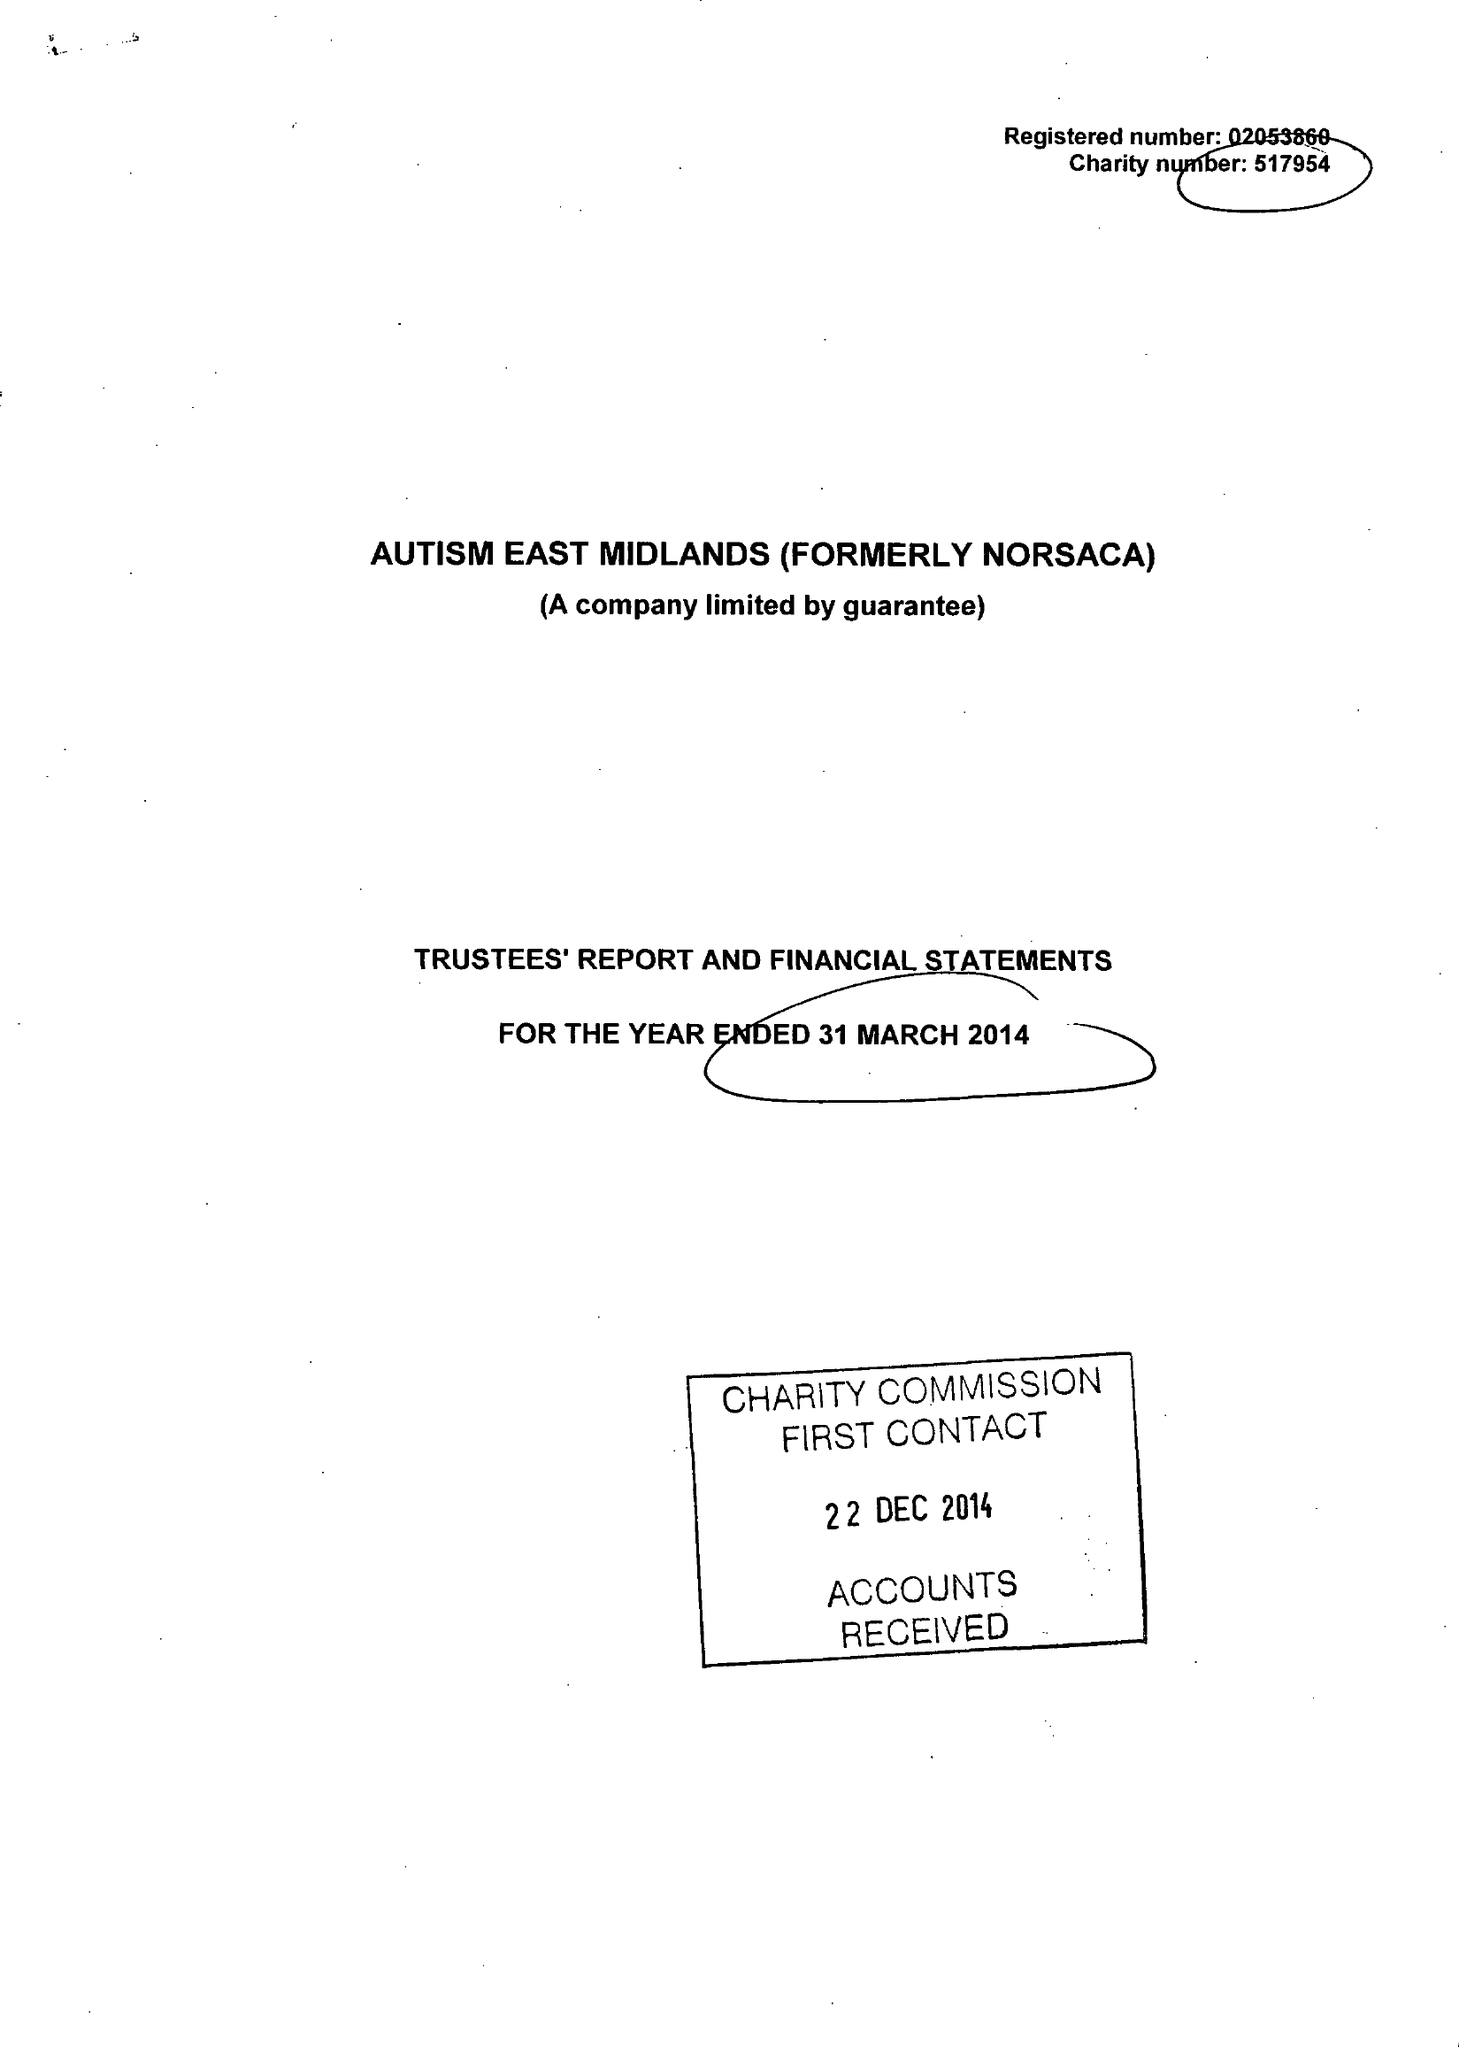What is the value for the address__post_town?
Answer the question using a single word or phrase. WORKSOP 